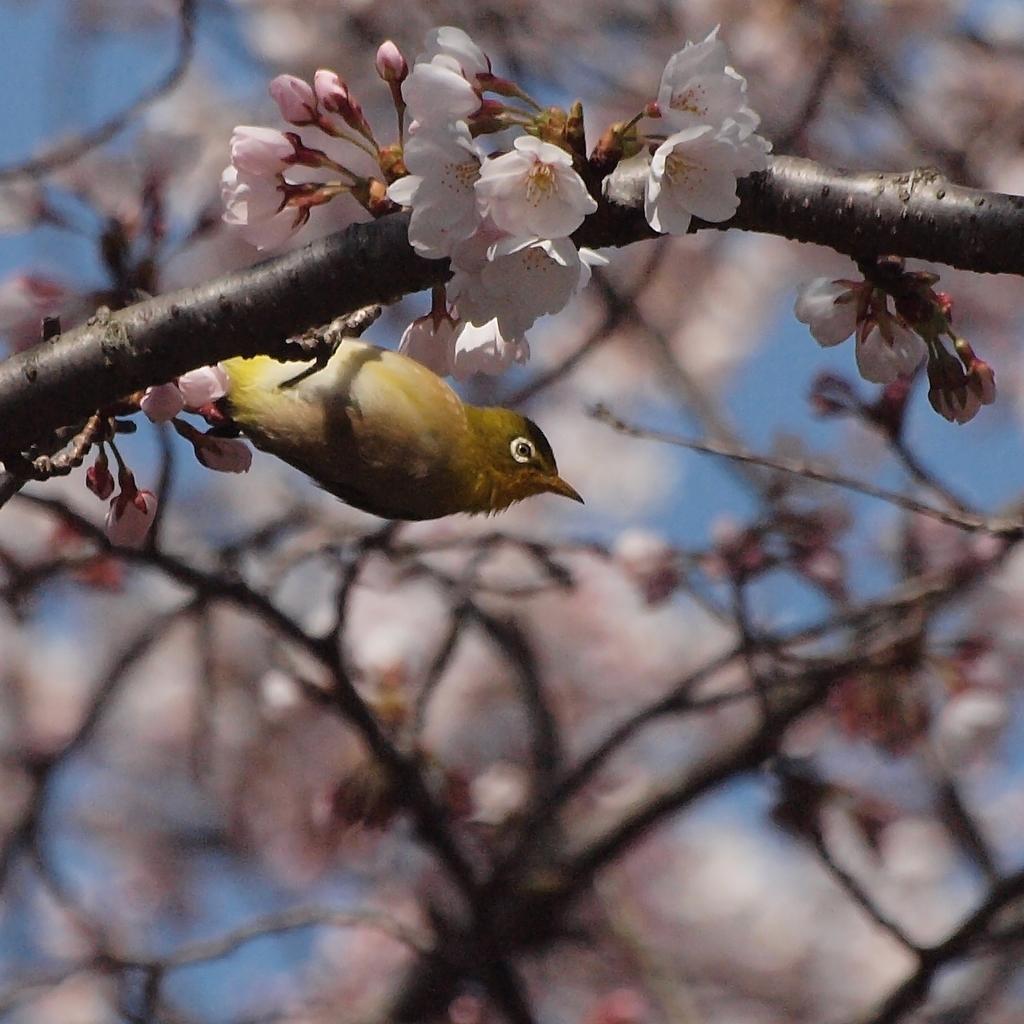Could you give a brief overview of what you see in this image? In this image we can see a bird, flowers, stem and we can also see a blurred background. 